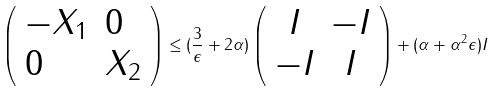<formula> <loc_0><loc_0><loc_500><loc_500>\left ( \begin{array} { l l } - X _ { 1 } & 0 \\ 0 & X _ { 2 } \end{array} \right ) \leq ( \frac { 3 } { \epsilon } + 2 \alpha ) \left ( \begin{array} { c c } I & - I \\ - I & I \end{array} \right ) + ( \alpha + \alpha ^ { 2 } \epsilon ) I</formula> 